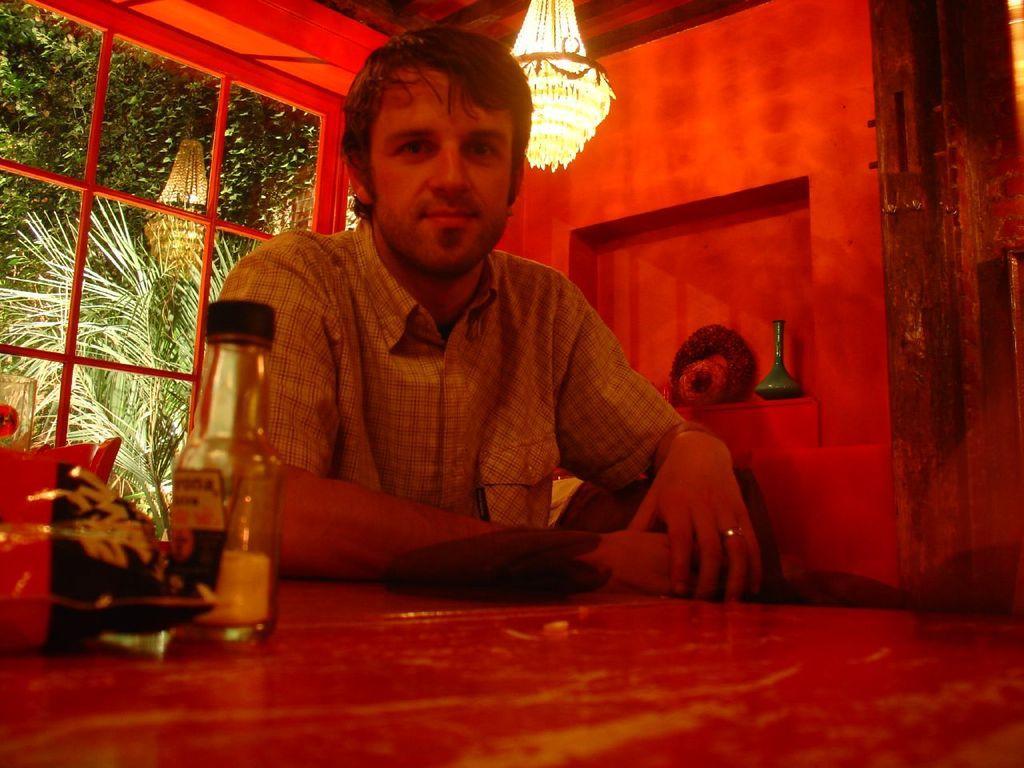How would you summarize this image in a sentence or two? In this picture is a person sitting with a table in front of him with packet and bottle and in the background there is a wall, lights and window 